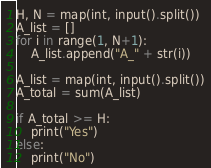Convert code to text. <code><loc_0><loc_0><loc_500><loc_500><_Python_>H, N = map(int, input().split())
A_list = []
for i in range(1, N+1):
    A_list.append("A_" + str(i))

A_list = map(int, input().split())
A_total = sum(A_list)

if A_total >= H:
    print("Yes")
else:
    print("No")</code> 